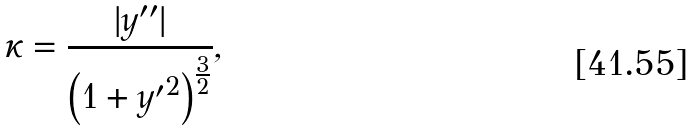<formula> <loc_0><loc_0><loc_500><loc_500>\kappa = { \frac { | y ^ { \prime \prime } | } { \left ( 1 + { y ^ { \prime } } ^ { 2 } \right ) ^ { \frac { 3 } { 2 } } } } ,</formula> 